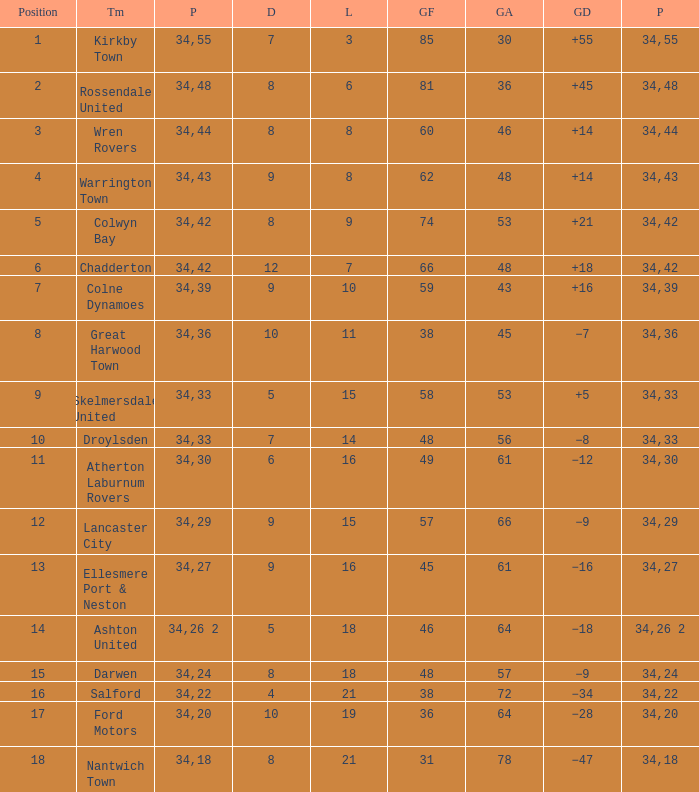What is the smallest number of goals against when 8 games were lost, and the goals for are 60? 46.0. 